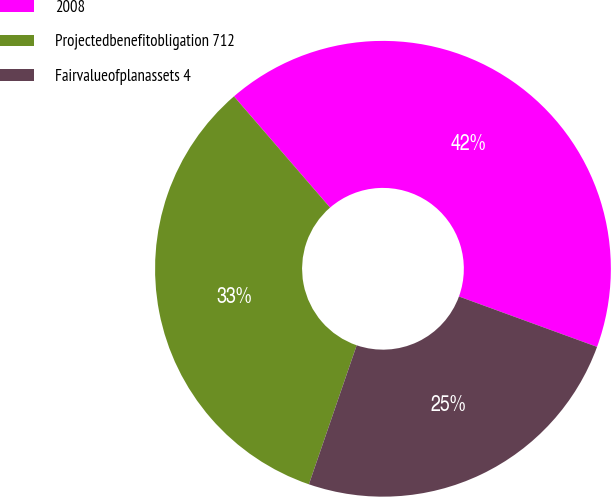Convert chart to OTSL. <chart><loc_0><loc_0><loc_500><loc_500><pie_chart><fcel>2008<fcel>Projectedbenefitobligation 712<fcel>Fairvalueofplanassets 4<nl><fcel>41.91%<fcel>33.39%<fcel>24.7%<nl></chart> 